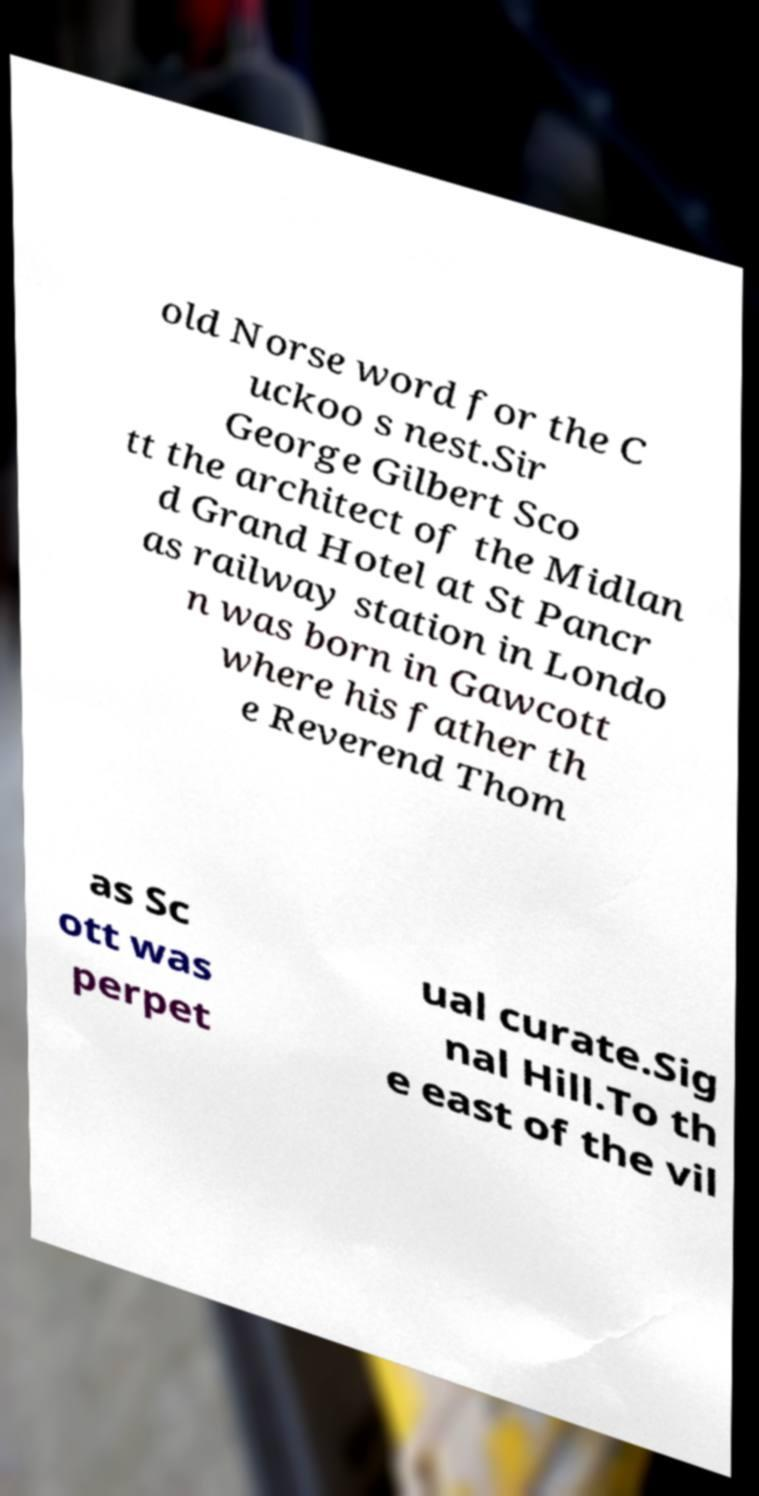Can you read and provide the text displayed in the image?This photo seems to have some interesting text. Can you extract and type it out for me? old Norse word for the C uckoo s nest.Sir George Gilbert Sco tt the architect of the Midlan d Grand Hotel at St Pancr as railway station in Londo n was born in Gawcott where his father th e Reverend Thom as Sc ott was perpet ual curate.Sig nal Hill.To th e east of the vil 